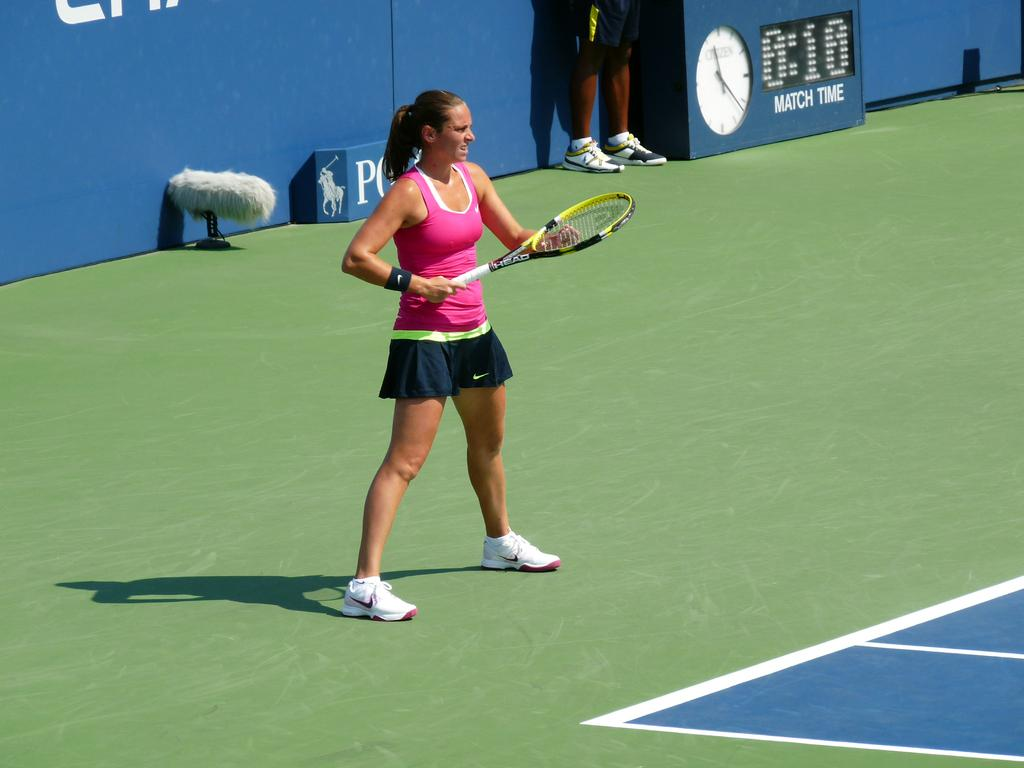Who is the main subject in the image? There is a woman in the image. What is the woman doing in the image? The woman is playing tennis. What tool is the woman using to play tennis? The woman is using a racket. What type of beast can be seen in the image? There is no beast present in the image; it features a woman playing tennis with a racket. 